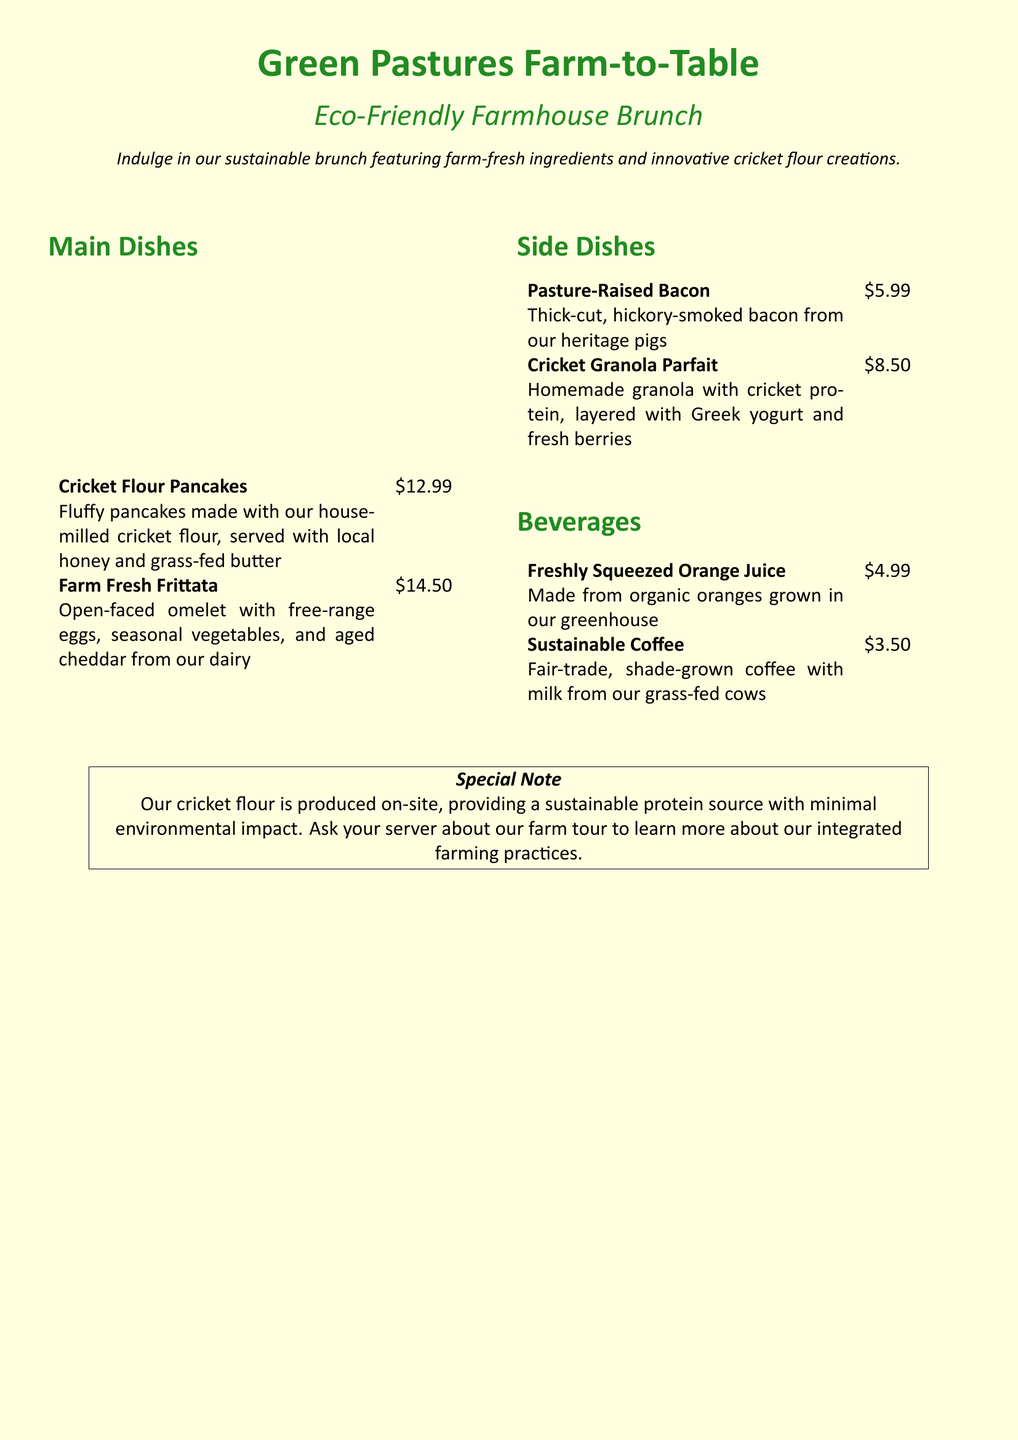What is the name of the restaurant? The name of the restaurant is highlighted in the title of the menu at the top of the document.
Answer: Green Pastures Farm-to-Table What is the price of Cricket Flour Pancakes? The price of the Cricket Flour Pancakes is listed next to the dish in the menu.
Answer: $12.99 What ingredient is used for the homemade granola? The ingredient used in the Cricket Granola Parfait is mentioned in the description of the dish.
Answer: Cricket protein How much does the Sustainable Coffee cost? The cost is provided next to the beverage in the menu section.
Answer: $3.50 What special note is provided at the bottom of the menu? The special note discusses the cricket flour's production and its impact, specified in a boxed section at the bottom.
Answer: Sustainable protein source How many side dishes are listed in the menu? The number of side dishes can be counted from the list.
Answer: 2 What type of eggs are used in the Farm Fresh Frittata? The type of eggs used in the frittata is mentioned in the dish's description.
Answer: Free-range eggs Which beverage is made from organic oranges? The beverage made from organic oranges is specified in the menu.
Answer: Freshly Squeezed Orange Juice What dairy product is mentioned as being from grass-fed cows? The dairy product is mentioned in the description of the Sustainable Coffee.
Answer: Milk 